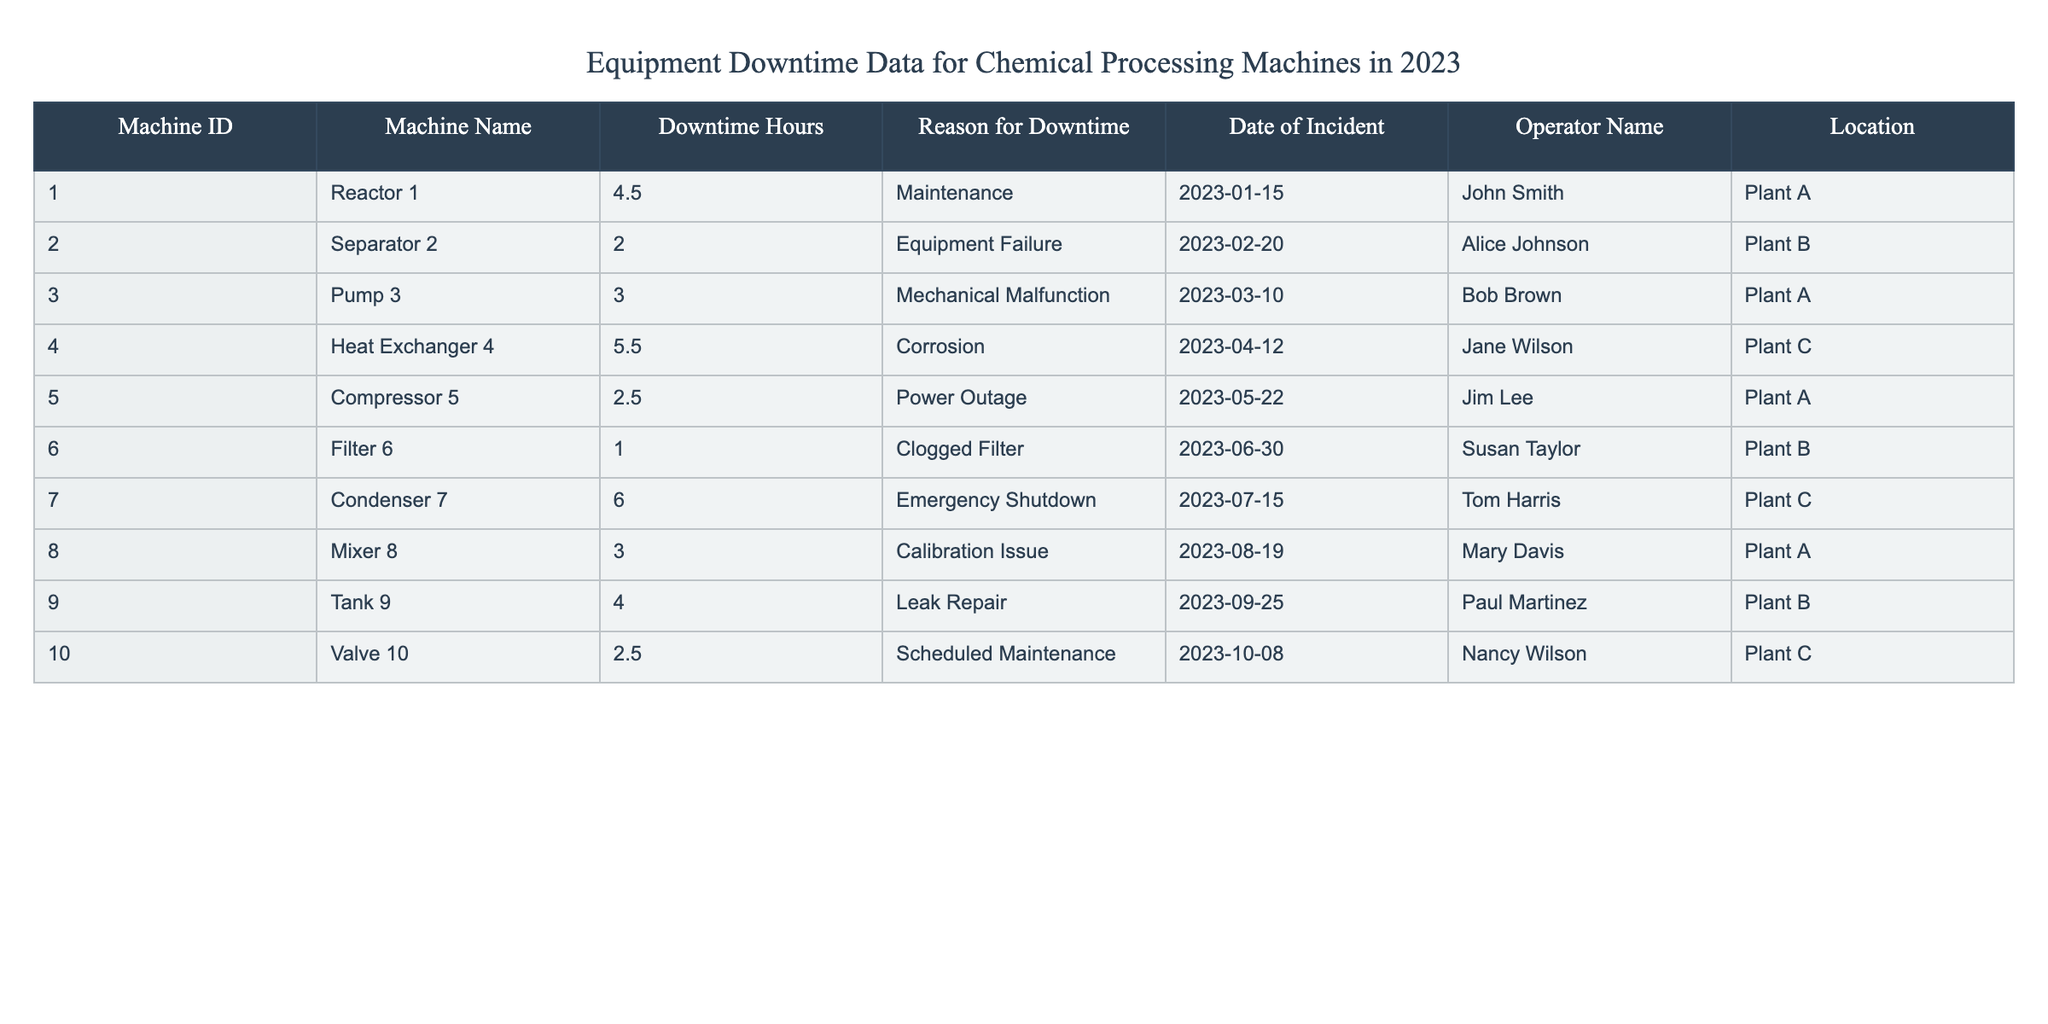What was the maximum downtime recorded? The maximum downtime recorded is determined by looking at the "Downtime Hours" column. The highest value is 6.0 hours for the "Condenser 7".
Answer: 6.0 hours How many incidents of downtime were recorded in Plant A? By filtering the rows where the "Location" is "Plant A", we see incidents for Reactor 1, Pump 3, and Mixer 8, which adds up to 3 incidents.
Answer: 3 incidents Which machine had downtime due to a power outage? Referring to the "Reason for Downtime" column, the "Compressor 5" had a downtime of 2.5 hours due to a power outage on May 22, 2023.
Answer: Compressor 5 What is the total downtime across all machines? We sum all the "Downtime Hours" values: 4.5 + 2.0 + 3.0 + 5.5 + 2.5 + 1.0 + 6.0 + 3.0 + 4.0 + 2.5 = 30.0 hours, which gives the total downtime.
Answer: 30.0 hours Did any incident occur on July 15, 2023? Checking the "Date of Incident" column, there is one incident recorded for "Condenser 7" on July 15, 2023, due to an emergency shutdown.
Answer: Yes What is the average downtime of all machines? To find the average downtime, we sum the "Downtime Hours" to get 30.0 hours and divide by the total number of incidents (10): 30.0 / 10 = 3.0 hours.
Answer: 3.0 hours Which operator was involved in the most downtime incidents? Counting the incidents for each operator, John Smith (3), Alice Johnson (1), Bob Brown (1), Jane Wilson (1), Jim Lee (1), Susan Taylor (1), Tom Harris (1), Mary Davis (1), Paul Martinez (1), Nancy Wilson (1). John Smith had the most with 3 incidents.
Answer: John Smith What was the reason for the longest downtime? Looking at the "Reason for Downtime" for the maximum downtime of 6.0 hours, which was due to an emergency shutdown for "Condenser 7".
Answer: Emergency Shutdown How many machines experienced mechanical issues? Examining the "Reason for Downtime", we find that "Pump 3" and "Condenser 7" had mechanical issues (mechanical malfunction with Pump 3 and emergency shutdown with Condenser 7), leading to 2 machines experiencing such issues.
Answer: 2 machines 